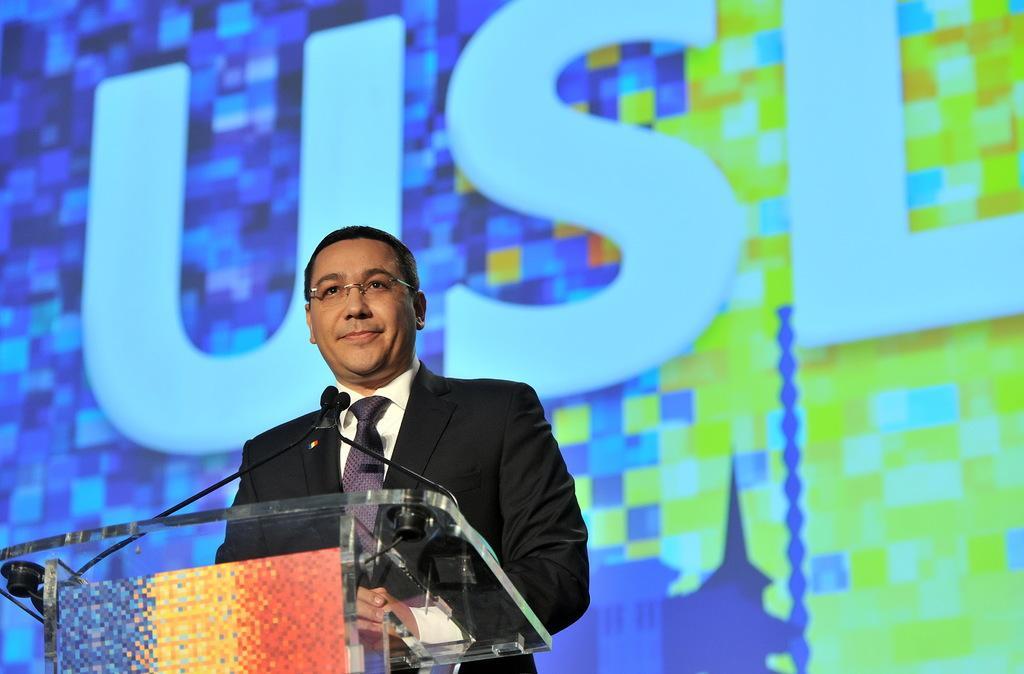Can you describe this image briefly? In this picture I can see a man standing near the podium, there are mikes on the podium, and in the background there is a board or a screen. 